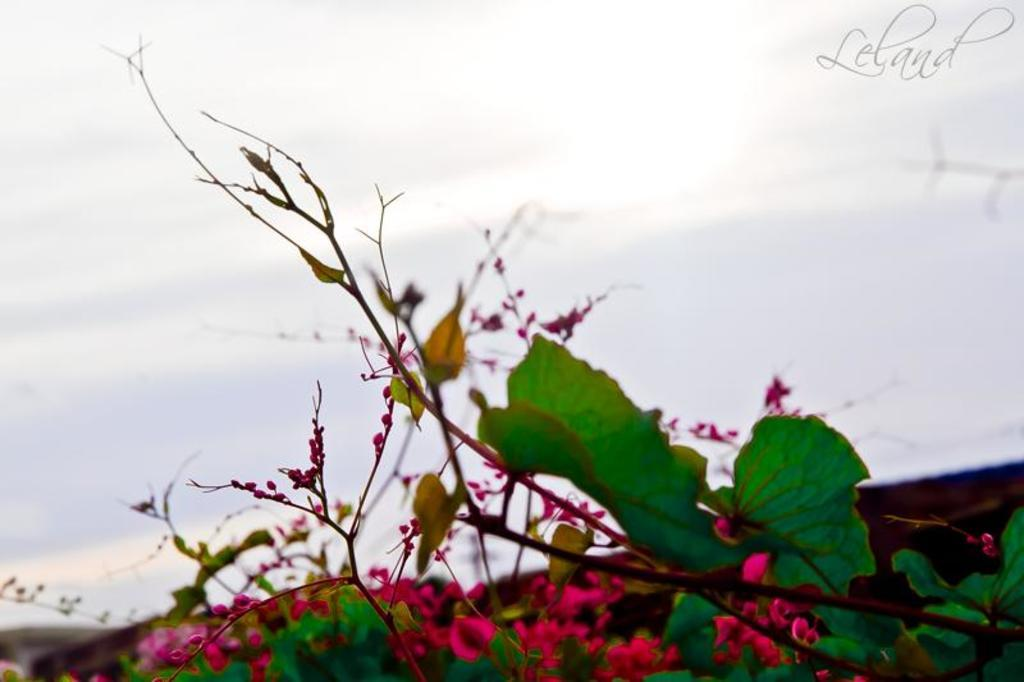What type of living organism is in the image? There is a plant in the image. What features can be observed on the plant? The plant has leaves, flowers, and buds. What can be seen in the background of the image? The sky is visible in the background of the image. What type of disease is affecting the plant in the image? There is no indication of any disease affecting the plant in the image. 